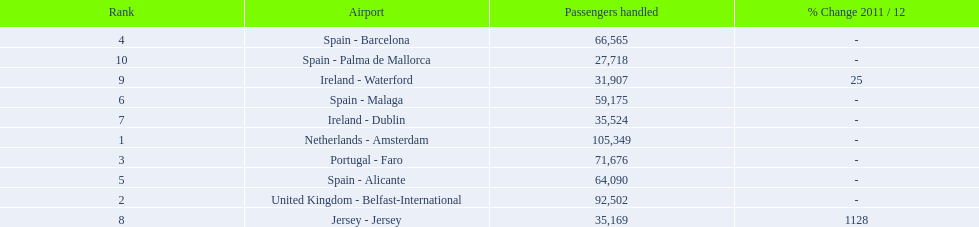Name all the london southend airports that did not list a change in 2001/12. Netherlands - Amsterdam, United Kingdom - Belfast-International, Portugal - Faro, Spain - Barcelona, Spain - Alicante, Spain - Malaga, Ireland - Dublin, Spain - Palma de Mallorca. What unchanged percentage airports from 2011/12 handled less then 50,000 passengers? Ireland - Dublin, Spain - Palma de Mallorca. What unchanged percentage airport from 2011/12 handled less then 50,000 passengers is the closest to the equator? Spain - Palma de Mallorca. 